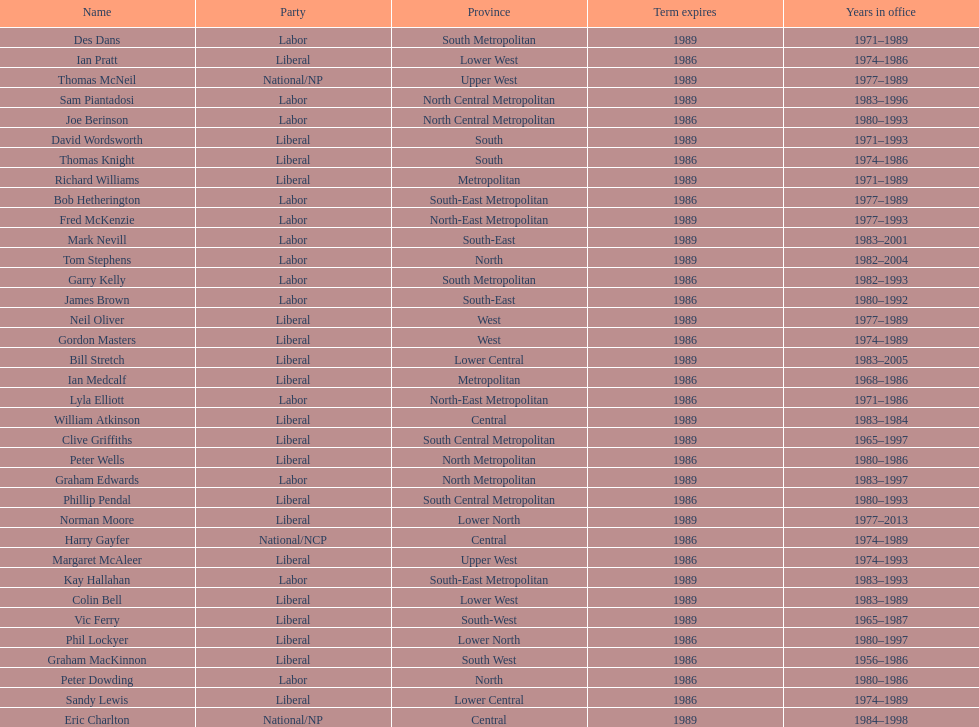What is the count of members with terms concluding in 1989? 9. 